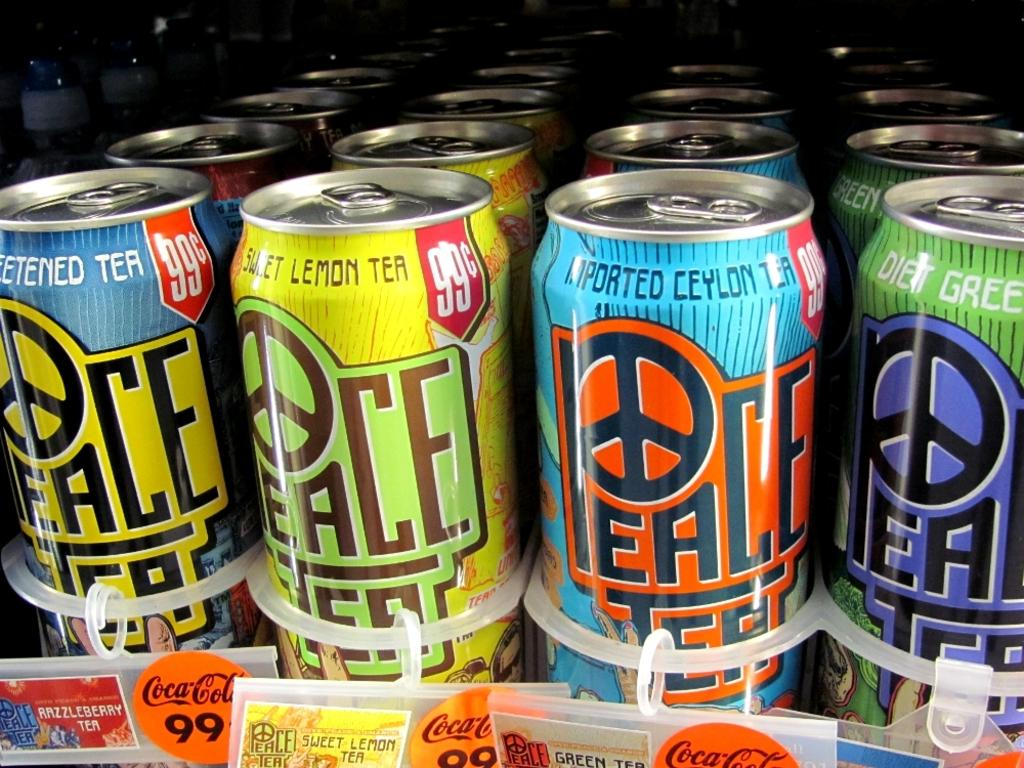<image>
Relay a brief, clear account of the picture shown. A store refrigerator shelf with cans of Peace Tea lined up. 